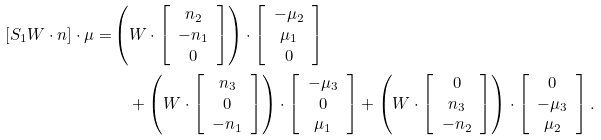Convert formula to latex. <formula><loc_0><loc_0><loc_500><loc_500>[ S _ { 1 } W \cdot n ] \cdot \mu = & \left ( W \cdot \left [ \begin{array} { c } n _ { 2 } \\ - n _ { 1 } \\ 0 \end{array} \right ] \right ) \cdot \left [ \begin{array} { c } - \mu _ { 2 } \\ \mu _ { 1 } \\ 0 \end{array} \right ] \\ & \quad + \left ( W \cdot \left [ \begin{array} { c } n _ { 3 } \\ 0 \\ - n _ { 1 } \end{array} \right ] \right ) \cdot \left [ \begin{array} { c } - \mu _ { 3 } \\ 0 \\ \mu _ { 1 } \end{array} \right ] + \left ( W \cdot \left [ \begin{array} { c } 0 \\ n _ { 3 } \\ - n _ { 2 } \end{array} \right ] \right ) \cdot \left [ \begin{array} { c } 0 \\ - \mu _ { 3 } \\ \mu _ { 2 } \end{array} \right ] .</formula> 